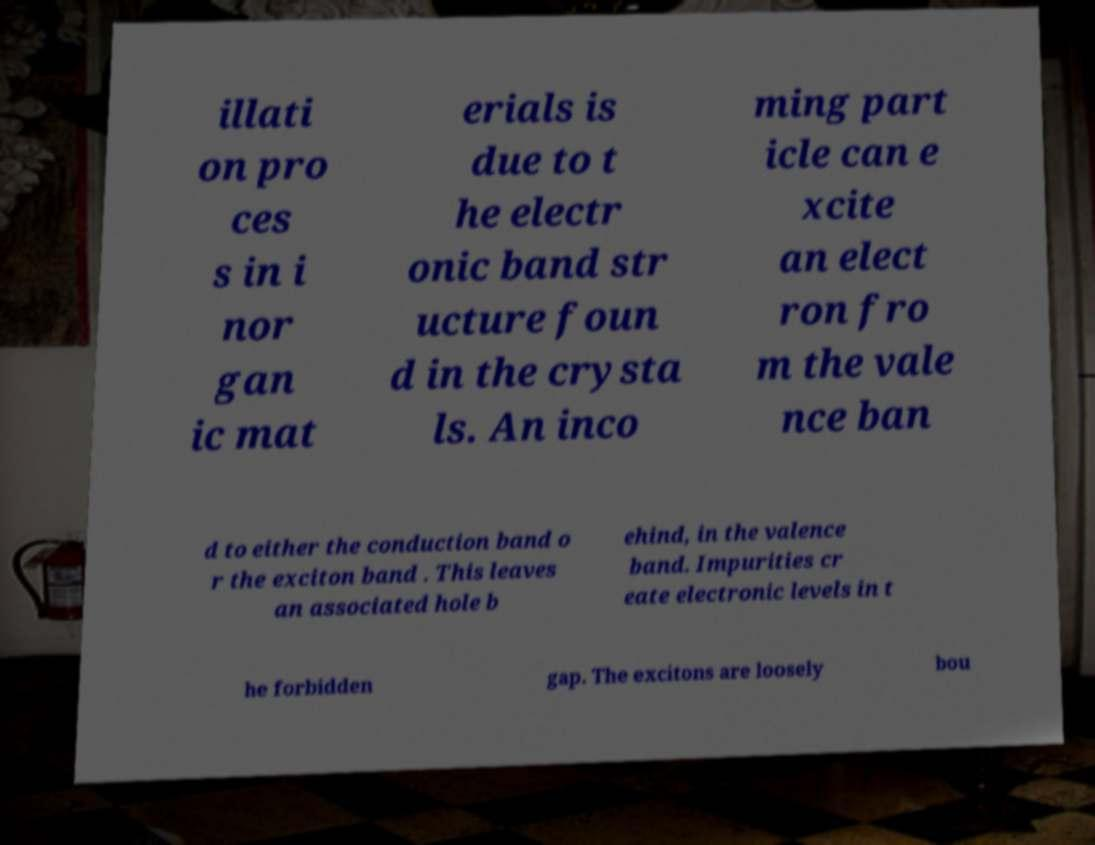There's text embedded in this image that I need extracted. Can you transcribe it verbatim? illati on pro ces s in i nor gan ic mat erials is due to t he electr onic band str ucture foun d in the crysta ls. An inco ming part icle can e xcite an elect ron fro m the vale nce ban d to either the conduction band o r the exciton band . This leaves an associated hole b ehind, in the valence band. Impurities cr eate electronic levels in t he forbidden gap. The excitons are loosely bou 